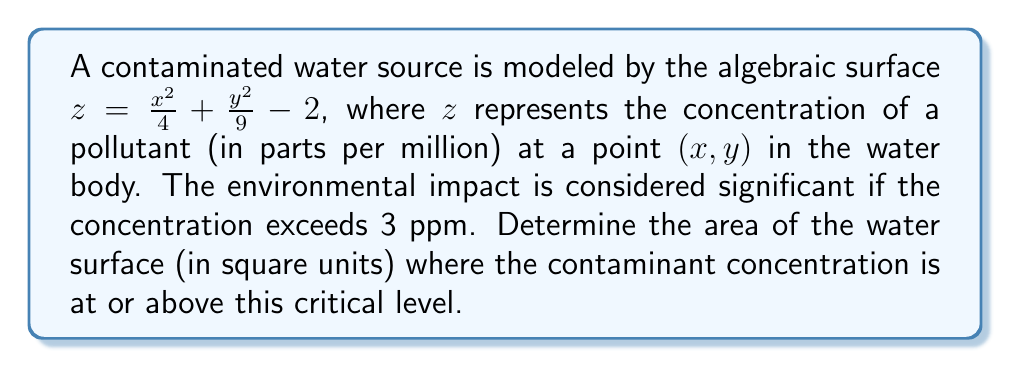Teach me how to tackle this problem. To solve this problem, we'll follow these steps:

1) The surface of the water is represented by the $xy$-plane, where $z = 0$. The area we're looking for is where the concentration is at least 3 ppm, so we need to find where $z \geq 3$.

2) Substituting this into our equation:

   $$3 \leq \frac{x^2}{4} + \frac{y^2}{9} - 2$$

3) Rearranging the inequality:

   $$5 \leq \frac{x^2}{4} + \frac{y^2}{9}$$

4) Multiplying both sides by 36:

   $$180 \leq 9x^2 + 4y^2$$

5) Dividing both sides by 180:

   $$1 \leq \frac{9x^2}{180} + \frac{4y^2}{180} = \frac{x^2}{20} + \frac{y^2}{45}$$

6) This is the equation of an ellipse. The general form of an ellipse equation is:

   $$\frac{x^2}{a^2} + \frac{y^2}{b^2} = 1$$

   where $a$ and $b$ are the lengths of the semi-major and semi-minor axes.

7) Comparing our equation to the general form, we can see that:

   $$a^2 = 20 \text{ and } b^2 = 45$$

8) Therefore, $a = \sqrt{20} = 2\sqrt{5}$ and $b = \sqrt{45} = 3\sqrt{5}$

9) The area of an ellipse is given by the formula $A = \pi ab$. Substituting our values:

   $$A = \pi(2\sqrt{5})(3\sqrt{5}) = 6\pi\sqrt{5^2} = 30\pi$$

Therefore, the area where the contaminant concentration is at or above the critical level is $30\pi$ square units.
Answer: $30\pi$ square units 